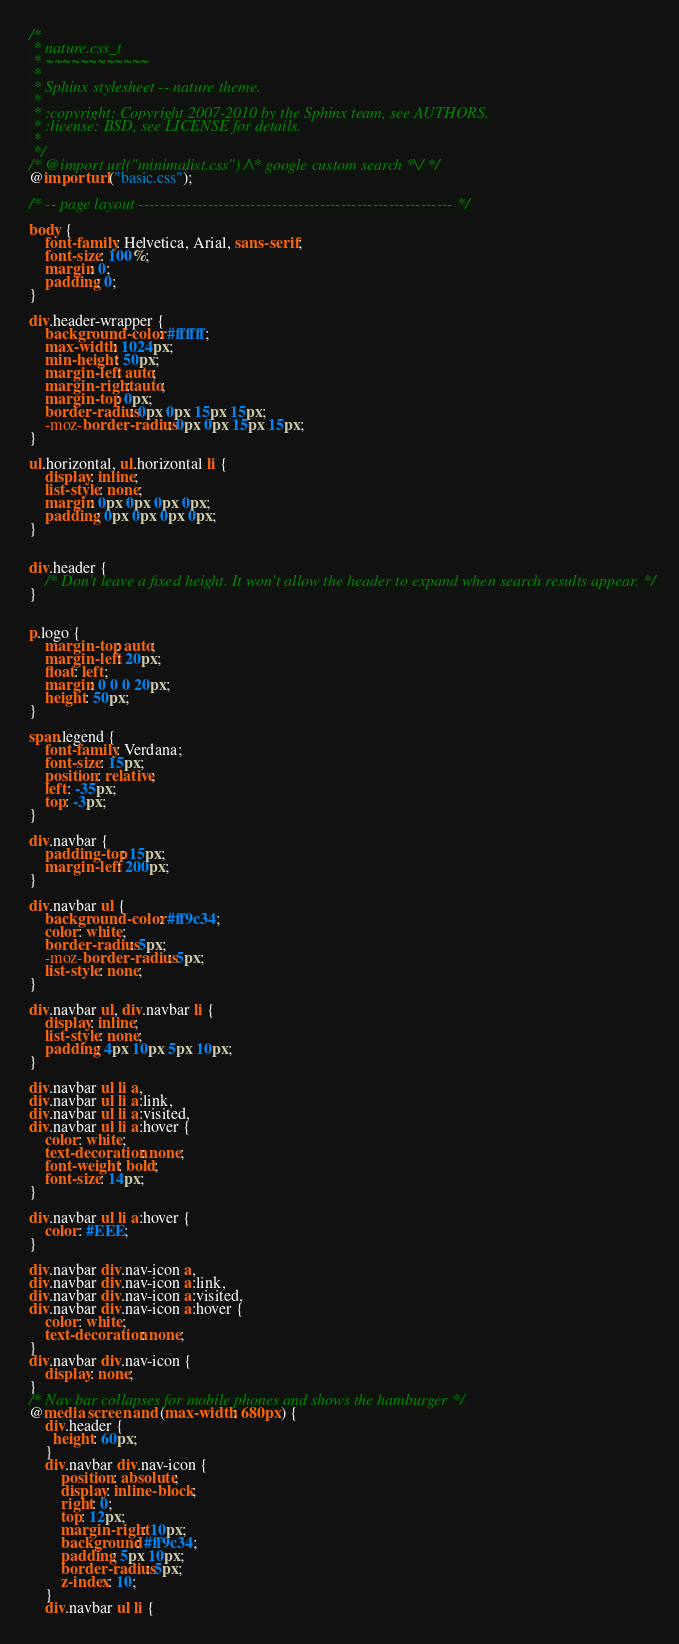<code> <loc_0><loc_0><loc_500><loc_500><_CSS_>/*
 * nature.css_t
 * ~~~~~~~~~~~~
 *
 * Sphinx stylesheet -- nature theme.
 *
 * :copyright: Copyright 2007-2010 by the Sphinx team, see AUTHORS.
 * :license: BSD, see LICENSE for details.
 *
 */
/* @import url("minimalist.css") /\* google custom search *\/ */
@import url("basic.css");

/* -- page layout ----------------------------------------------------------- */

body {
    font-family: Helvetica, Arial, sans-serif;
    font-size: 100%;
    margin: 0;
    padding: 0;
}

div.header-wrapper {
    background-color: #ffffff;
    max-width: 1024px;
    min-height: 50px;
    margin-left: auto;
    margin-right: auto;
    margin-top: 0px;
    border-radius: 0px 0px 15px 15px;
    -moz-border-radius: 0px 0px 15px 15px;
}

ul.horizontal, ul.horizontal li {
    display: inline;
    list-style: none;
    margin: 0px 0px 0px 0px;
    padding: 0px 0px 0px 0px;
}


div.header {
    /* Don't leave a fixed height. It won't allow the header to expand when search results appear. */
}


p.logo {
    margin-top: auto;
    margin-left: 20px;
    float: left;
    margin: 0 0 0 20px;
    height: 50px;
}

span.legend {
    font-family: Verdana;
    font-size: 15px;
    position: relative;
    left: -35px;
    top: -3px;
}

div.navbar {
    padding-top: 15px;
    margin-left: 200px;
}

div.navbar ul {
    background-color: #ff9c34;
    color: white;
    border-radius: 5px;
    -moz-border-radius: 5px;
    list-style: none;
}

div.navbar ul, div.navbar li {
    display: inline;
    list-style: none;
    padding: 4px 10px 5px 10px;
}

div.navbar ul li a,
div.navbar ul li a:link,
div.navbar ul li a:visited,
div.navbar ul li a:hover {
    color: white;
    text-decoration: none;
    font-weight: bold;
    font-size: 14px;
}

div.navbar ul li a:hover {
    color: #EEE;
}

div.navbar div.nav-icon a,
div.navbar div.nav-icon a:link,
div.navbar div.nav-icon a:visited,
div.navbar div.nav-icon a:hover {
    color: white;
    text-decoration: none;
}
div.navbar div.nav-icon {
    display: none;
}
/* Nav bar collapses for mobile phones and shows the hamburger */
@media screen and (max-width: 680px) {
    div.header {
      height: 60px;
    }
    div.navbar div.nav-icon {
        position: absolute;
        display: inline-block;
        right: 0;
        top: 12px;
        margin-right: 10px;
        background: #ff9c34;
        padding: 5px 10px;
        border-radius: 5px;
        z-index: 10;
    }
    div.navbar ul li {</code> 